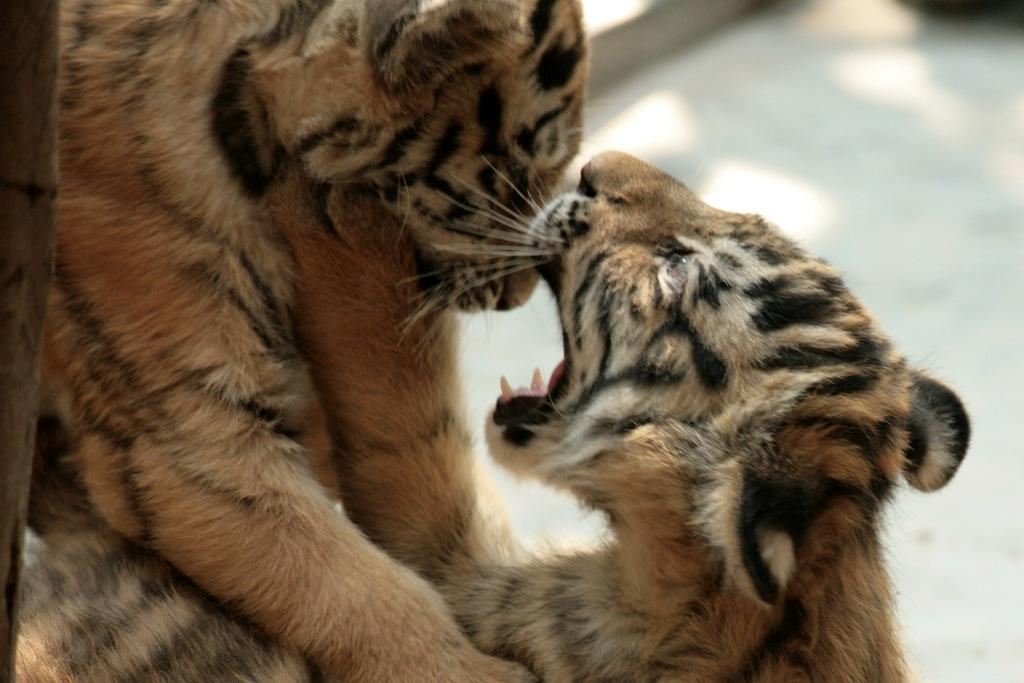What type of animals are on the floor in the image? The facts provided do not specify the type of animals on the floor. What object can be seen at the side in the image? There is a stick visible at the side in the image. How many worms can be seen crawling in the quicksand in the image? There is no quicksand or worms present in the image. 